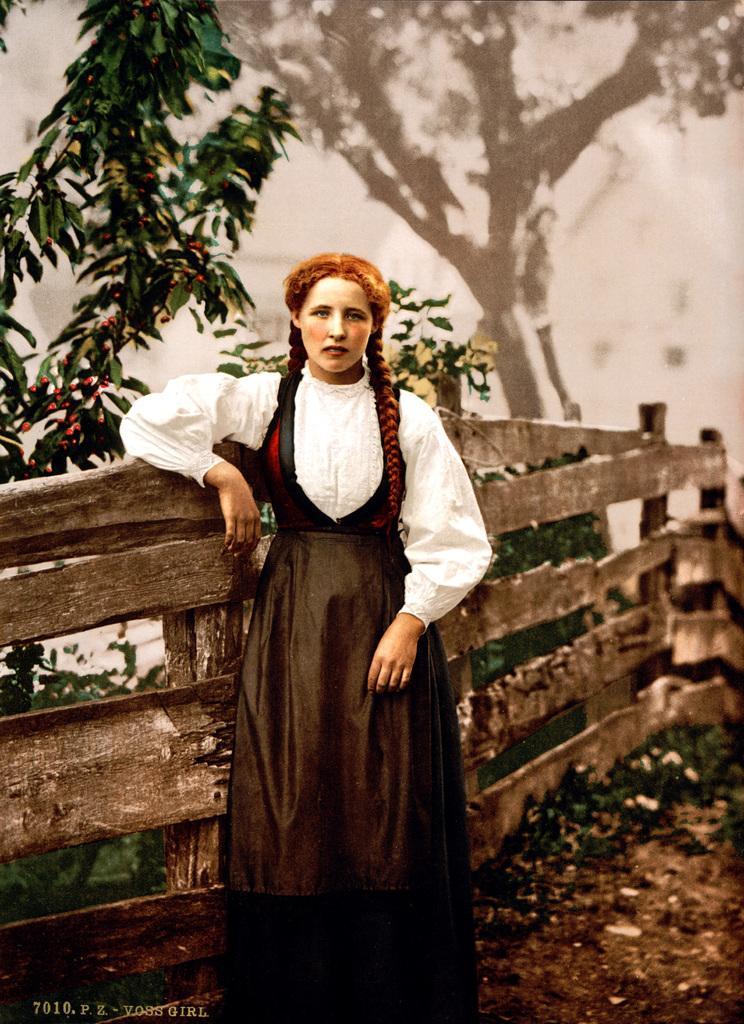Can you describe this image briefly? In this image we can see a woman standing and posing for a photo and there is a wooden fence and we can see some plants and trees. 